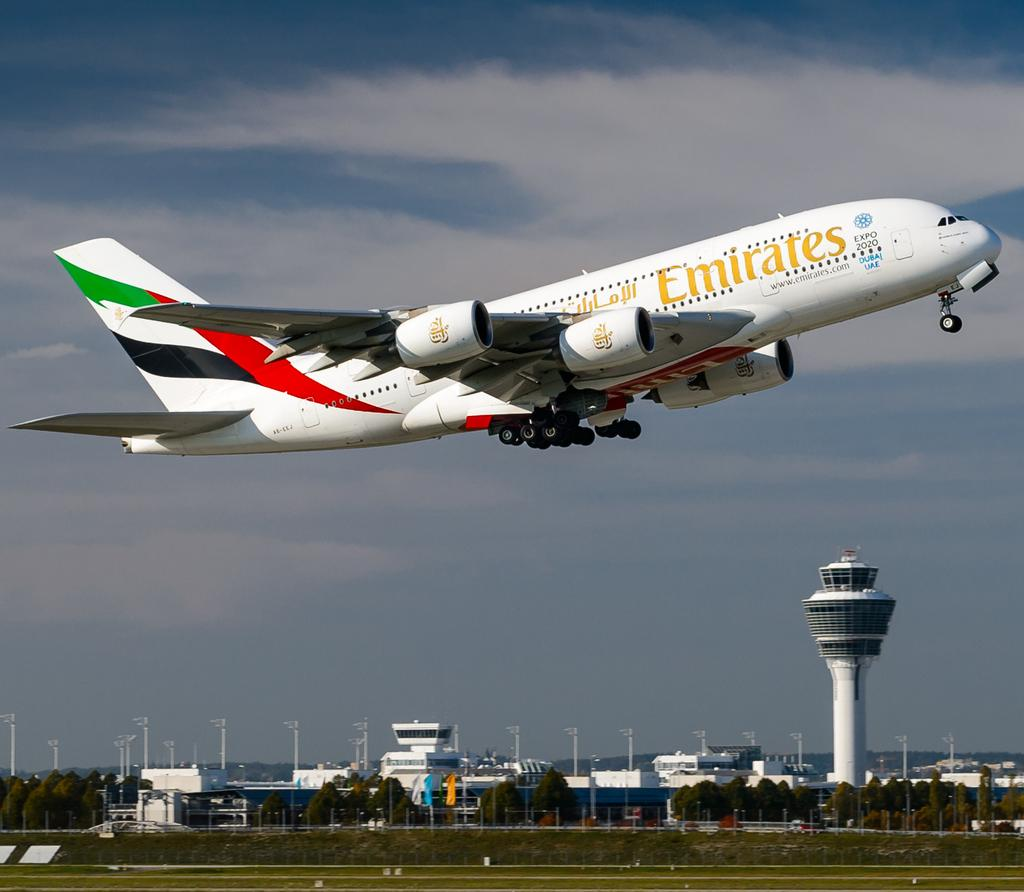<image>
Write a terse but informative summary of the picture. a white plane with the arabe emirates airline emblazoned on its side. 